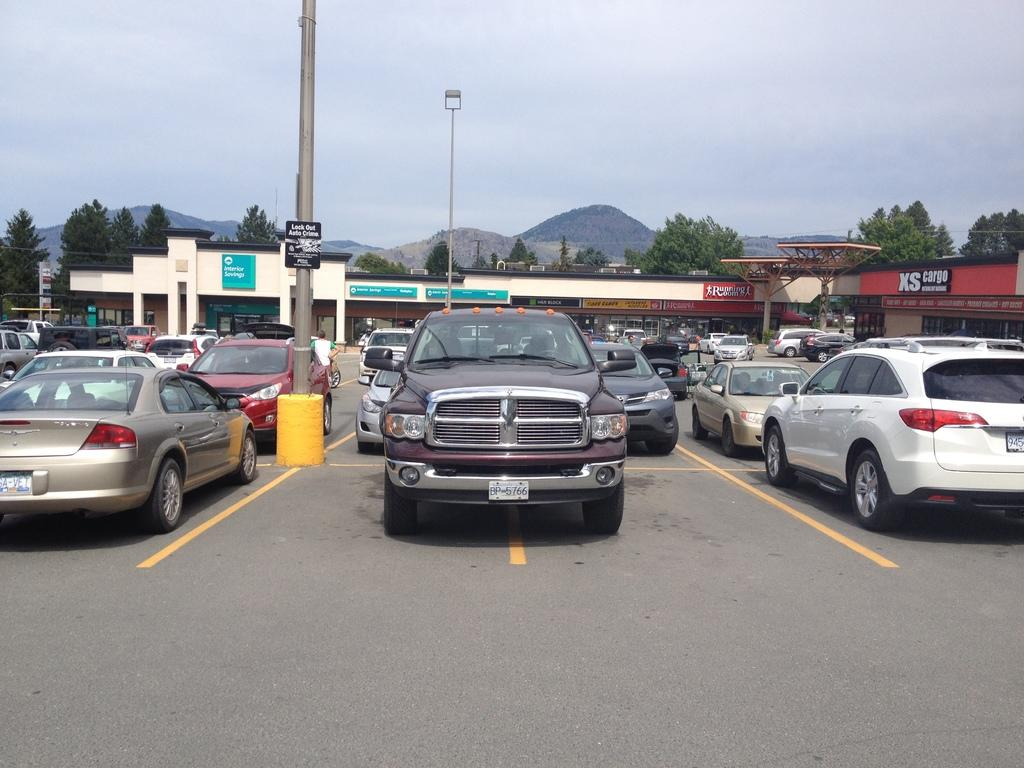What can be seen in the foreground of the image? There are vehicles on the road and poles in the foreground of the image. What is visible in the background of the image? There are buildings, posters, trees, mountains, and sky visible in the background of the image. Can you describe the sky in the image? The sky is visible in the background of the image, and there is a cloud visible in the sky. What type of leather is being used to cover the mouth of the vehicle in the image? There is no leather or mouth visible in the image; it features vehicles on the road and poles in the foreground, as well as buildings, posters, trees, mountains, and sky in the background. 